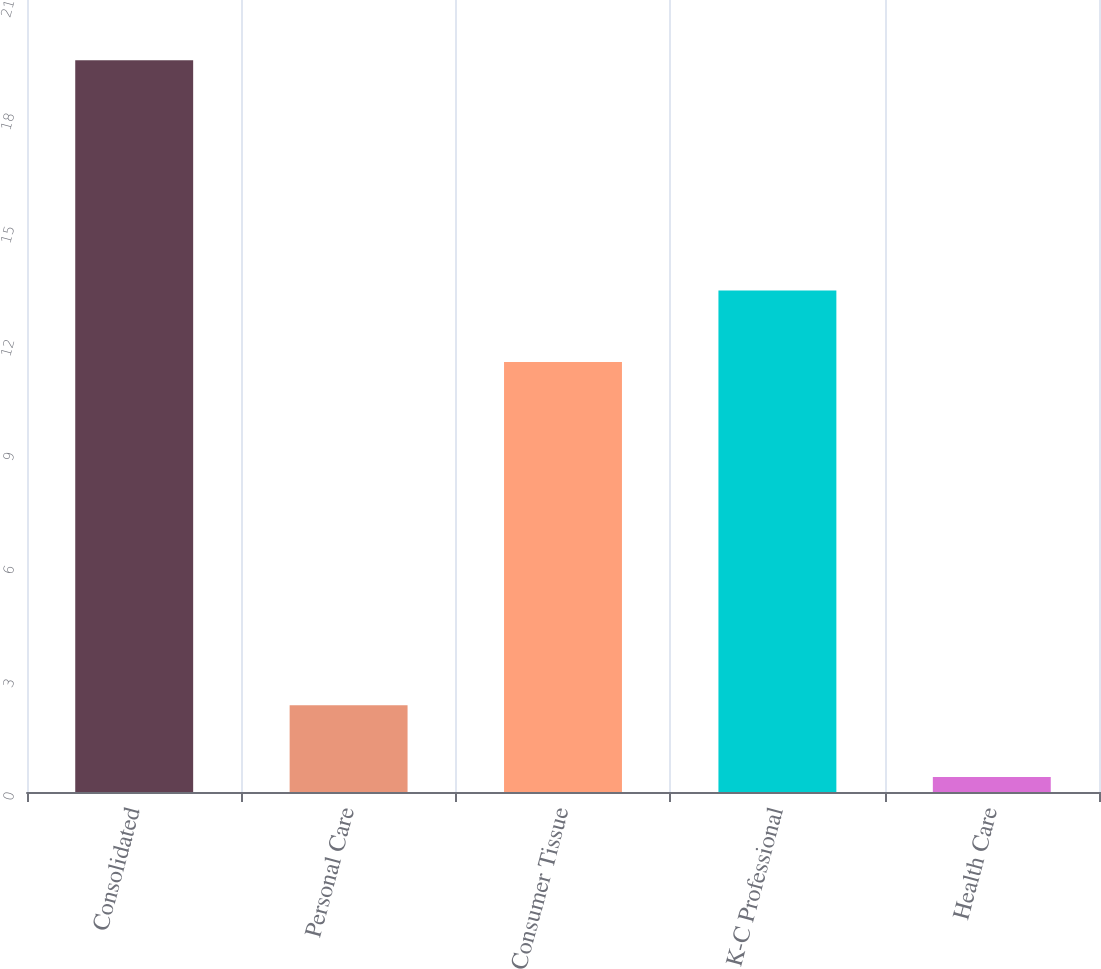Convert chart. <chart><loc_0><loc_0><loc_500><loc_500><bar_chart><fcel>Consolidated<fcel>Personal Care<fcel>Consumer Tissue<fcel>K-C Professional<fcel>Health Care<nl><fcel>19.4<fcel>2.3<fcel>11.4<fcel>13.3<fcel>0.4<nl></chart> 